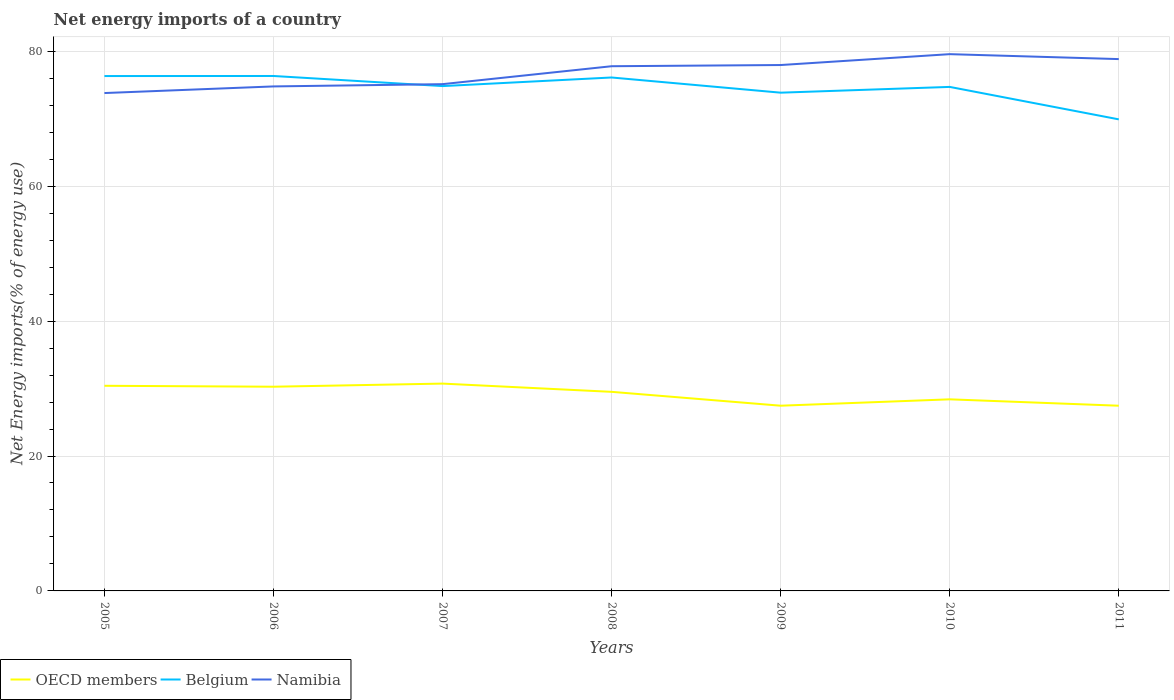How many different coloured lines are there?
Ensure brevity in your answer.  3. Is the number of lines equal to the number of legend labels?
Your answer should be very brief. Yes. Across all years, what is the maximum net energy imports in OECD members?
Your response must be concise. 27.46. What is the total net energy imports in Belgium in the graph?
Your answer should be compact. 2.46. What is the difference between the highest and the second highest net energy imports in OECD members?
Your response must be concise. 3.28. How many lines are there?
Your answer should be very brief. 3. What is the difference between two consecutive major ticks on the Y-axis?
Give a very brief answer. 20. Does the graph contain any zero values?
Keep it short and to the point. No. Does the graph contain grids?
Your response must be concise. Yes. Where does the legend appear in the graph?
Provide a short and direct response. Bottom left. How are the legend labels stacked?
Keep it short and to the point. Horizontal. What is the title of the graph?
Give a very brief answer. Net energy imports of a country. What is the label or title of the Y-axis?
Your answer should be compact. Net Energy imports(% of energy use). What is the Net Energy imports(% of energy use) in OECD members in 2005?
Make the answer very short. 30.41. What is the Net Energy imports(% of energy use) in Belgium in 2005?
Ensure brevity in your answer.  76.33. What is the Net Energy imports(% of energy use) in Namibia in 2005?
Offer a terse response. 73.81. What is the Net Energy imports(% of energy use) of OECD members in 2006?
Provide a short and direct response. 30.27. What is the Net Energy imports(% of energy use) of Belgium in 2006?
Offer a very short reply. 76.34. What is the Net Energy imports(% of energy use) of Namibia in 2006?
Your answer should be compact. 74.79. What is the Net Energy imports(% of energy use) in OECD members in 2007?
Offer a terse response. 30.73. What is the Net Energy imports(% of energy use) in Belgium in 2007?
Ensure brevity in your answer.  74.84. What is the Net Energy imports(% of energy use) in Namibia in 2007?
Offer a terse response. 75.13. What is the Net Energy imports(% of energy use) of OECD members in 2008?
Make the answer very short. 29.51. What is the Net Energy imports(% of energy use) of Belgium in 2008?
Offer a very short reply. 76.11. What is the Net Energy imports(% of energy use) in Namibia in 2008?
Keep it short and to the point. 77.78. What is the Net Energy imports(% of energy use) of OECD members in 2009?
Offer a terse response. 27.46. What is the Net Energy imports(% of energy use) in Belgium in 2009?
Provide a succinct answer. 73.86. What is the Net Energy imports(% of energy use) in Namibia in 2009?
Provide a short and direct response. 77.96. What is the Net Energy imports(% of energy use) in OECD members in 2010?
Make the answer very short. 28.4. What is the Net Energy imports(% of energy use) in Belgium in 2010?
Give a very brief answer. 74.72. What is the Net Energy imports(% of energy use) of Namibia in 2010?
Ensure brevity in your answer.  79.57. What is the Net Energy imports(% of energy use) in OECD members in 2011?
Provide a succinct answer. 27.46. What is the Net Energy imports(% of energy use) in Belgium in 2011?
Provide a succinct answer. 69.91. What is the Net Energy imports(% of energy use) of Namibia in 2011?
Offer a terse response. 78.84. Across all years, what is the maximum Net Energy imports(% of energy use) of OECD members?
Offer a very short reply. 30.73. Across all years, what is the maximum Net Energy imports(% of energy use) of Belgium?
Keep it short and to the point. 76.34. Across all years, what is the maximum Net Energy imports(% of energy use) of Namibia?
Offer a very short reply. 79.57. Across all years, what is the minimum Net Energy imports(% of energy use) in OECD members?
Your answer should be very brief. 27.46. Across all years, what is the minimum Net Energy imports(% of energy use) in Belgium?
Give a very brief answer. 69.91. Across all years, what is the minimum Net Energy imports(% of energy use) of Namibia?
Provide a succinct answer. 73.81. What is the total Net Energy imports(% of energy use) in OECD members in the graph?
Provide a short and direct response. 204.25. What is the total Net Energy imports(% of energy use) in Belgium in the graph?
Keep it short and to the point. 522.1. What is the total Net Energy imports(% of energy use) of Namibia in the graph?
Ensure brevity in your answer.  537.88. What is the difference between the Net Energy imports(% of energy use) of OECD members in 2005 and that in 2006?
Your response must be concise. 0.14. What is the difference between the Net Energy imports(% of energy use) in Belgium in 2005 and that in 2006?
Give a very brief answer. -0.01. What is the difference between the Net Energy imports(% of energy use) in Namibia in 2005 and that in 2006?
Make the answer very short. -0.98. What is the difference between the Net Energy imports(% of energy use) in OECD members in 2005 and that in 2007?
Provide a short and direct response. -0.32. What is the difference between the Net Energy imports(% of energy use) in Belgium in 2005 and that in 2007?
Give a very brief answer. 1.49. What is the difference between the Net Energy imports(% of energy use) of Namibia in 2005 and that in 2007?
Make the answer very short. -1.32. What is the difference between the Net Energy imports(% of energy use) of OECD members in 2005 and that in 2008?
Your answer should be very brief. 0.9. What is the difference between the Net Energy imports(% of energy use) in Belgium in 2005 and that in 2008?
Ensure brevity in your answer.  0.21. What is the difference between the Net Energy imports(% of energy use) in Namibia in 2005 and that in 2008?
Give a very brief answer. -3.98. What is the difference between the Net Energy imports(% of energy use) of OECD members in 2005 and that in 2009?
Your answer should be compact. 2.95. What is the difference between the Net Energy imports(% of energy use) of Belgium in 2005 and that in 2009?
Your answer should be very brief. 2.46. What is the difference between the Net Energy imports(% of energy use) in Namibia in 2005 and that in 2009?
Provide a short and direct response. -4.15. What is the difference between the Net Energy imports(% of energy use) of OECD members in 2005 and that in 2010?
Make the answer very short. 2.01. What is the difference between the Net Energy imports(% of energy use) of Belgium in 2005 and that in 2010?
Ensure brevity in your answer.  1.61. What is the difference between the Net Energy imports(% of energy use) in Namibia in 2005 and that in 2010?
Offer a terse response. -5.76. What is the difference between the Net Energy imports(% of energy use) of OECD members in 2005 and that in 2011?
Provide a succinct answer. 2.96. What is the difference between the Net Energy imports(% of energy use) of Belgium in 2005 and that in 2011?
Make the answer very short. 6.42. What is the difference between the Net Energy imports(% of energy use) of Namibia in 2005 and that in 2011?
Your response must be concise. -5.03. What is the difference between the Net Energy imports(% of energy use) of OECD members in 2006 and that in 2007?
Provide a succinct answer. -0.46. What is the difference between the Net Energy imports(% of energy use) of Belgium in 2006 and that in 2007?
Offer a very short reply. 1.5. What is the difference between the Net Energy imports(% of energy use) of Namibia in 2006 and that in 2007?
Provide a succinct answer. -0.34. What is the difference between the Net Energy imports(% of energy use) in OECD members in 2006 and that in 2008?
Provide a short and direct response. 0.76. What is the difference between the Net Energy imports(% of energy use) in Belgium in 2006 and that in 2008?
Give a very brief answer. 0.22. What is the difference between the Net Energy imports(% of energy use) of Namibia in 2006 and that in 2008?
Your answer should be very brief. -3. What is the difference between the Net Energy imports(% of energy use) of OECD members in 2006 and that in 2009?
Give a very brief answer. 2.82. What is the difference between the Net Energy imports(% of energy use) in Belgium in 2006 and that in 2009?
Offer a terse response. 2.47. What is the difference between the Net Energy imports(% of energy use) of Namibia in 2006 and that in 2009?
Give a very brief answer. -3.17. What is the difference between the Net Energy imports(% of energy use) of OECD members in 2006 and that in 2010?
Your answer should be compact. 1.87. What is the difference between the Net Energy imports(% of energy use) in Belgium in 2006 and that in 2010?
Offer a very short reply. 1.62. What is the difference between the Net Energy imports(% of energy use) in Namibia in 2006 and that in 2010?
Your response must be concise. -4.78. What is the difference between the Net Energy imports(% of energy use) in OECD members in 2006 and that in 2011?
Provide a succinct answer. 2.82. What is the difference between the Net Energy imports(% of energy use) in Belgium in 2006 and that in 2011?
Offer a terse response. 6.43. What is the difference between the Net Energy imports(% of energy use) in Namibia in 2006 and that in 2011?
Give a very brief answer. -4.05. What is the difference between the Net Energy imports(% of energy use) of OECD members in 2007 and that in 2008?
Ensure brevity in your answer.  1.22. What is the difference between the Net Energy imports(% of energy use) of Belgium in 2007 and that in 2008?
Offer a terse response. -1.27. What is the difference between the Net Energy imports(% of energy use) of Namibia in 2007 and that in 2008?
Ensure brevity in your answer.  -2.66. What is the difference between the Net Energy imports(% of energy use) of OECD members in 2007 and that in 2009?
Your answer should be very brief. 3.28. What is the difference between the Net Energy imports(% of energy use) in Belgium in 2007 and that in 2009?
Your answer should be very brief. 0.98. What is the difference between the Net Energy imports(% of energy use) of Namibia in 2007 and that in 2009?
Provide a succinct answer. -2.83. What is the difference between the Net Energy imports(% of energy use) of OECD members in 2007 and that in 2010?
Offer a very short reply. 2.33. What is the difference between the Net Energy imports(% of energy use) of Belgium in 2007 and that in 2010?
Offer a very short reply. 0.12. What is the difference between the Net Energy imports(% of energy use) of Namibia in 2007 and that in 2010?
Make the answer very short. -4.45. What is the difference between the Net Energy imports(% of energy use) of OECD members in 2007 and that in 2011?
Provide a succinct answer. 3.28. What is the difference between the Net Energy imports(% of energy use) of Belgium in 2007 and that in 2011?
Your answer should be compact. 4.93. What is the difference between the Net Energy imports(% of energy use) of Namibia in 2007 and that in 2011?
Your answer should be compact. -3.71. What is the difference between the Net Energy imports(% of energy use) in OECD members in 2008 and that in 2009?
Offer a very short reply. 2.06. What is the difference between the Net Energy imports(% of energy use) in Belgium in 2008 and that in 2009?
Offer a terse response. 2.25. What is the difference between the Net Energy imports(% of energy use) in Namibia in 2008 and that in 2009?
Provide a short and direct response. -0.18. What is the difference between the Net Energy imports(% of energy use) of OECD members in 2008 and that in 2010?
Offer a very short reply. 1.11. What is the difference between the Net Energy imports(% of energy use) of Belgium in 2008 and that in 2010?
Make the answer very short. 1.4. What is the difference between the Net Energy imports(% of energy use) in Namibia in 2008 and that in 2010?
Offer a terse response. -1.79. What is the difference between the Net Energy imports(% of energy use) of OECD members in 2008 and that in 2011?
Give a very brief answer. 2.06. What is the difference between the Net Energy imports(% of energy use) of Belgium in 2008 and that in 2011?
Provide a short and direct response. 6.21. What is the difference between the Net Energy imports(% of energy use) of Namibia in 2008 and that in 2011?
Your answer should be compact. -1.06. What is the difference between the Net Energy imports(% of energy use) of OECD members in 2009 and that in 2010?
Ensure brevity in your answer.  -0.95. What is the difference between the Net Energy imports(% of energy use) in Belgium in 2009 and that in 2010?
Keep it short and to the point. -0.86. What is the difference between the Net Energy imports(% of energy use) of Namibia in 2009 and that in 2010?
Ensure brevity in your answer.  -1.61. What is the difference between the Net Energy imports(% of energy use) of OECD members in 2009 and that in 2011?
Your response must be concise. 0. What is the difference between the Net Energy imports(% of energy use) of Belgium in 2009 and that in 2011?
Your answer should be compact. 3.96. What is the difference between the Net Energy imports(% of energy use) of Namibia in 2009 and that in 2011?
Your response must be concise. -0.88. What is the difference between the Net Energy imports(% of energy use) in OECD members in 2010 and that in 2011?
Your answer should be compact. 0.95. What is the difference between the Net Energy imports(% of energy use) of Belgium in 2010 and that in 2011?
Provide a succinct answer. 4.81. What is the difference between the Net Energy imports(% of energy use) in Namibia in 2010 and that in 2011?
Offer a very short reply. 0.73. What is the difference between the Net Energy imports(% of energy use) of OECD members in 2005 and the Net Energy imports(% of energy use) of Belgium in 2006?
Your response must be concise. -45.93. What is the difference between the Net Energy imports(% of energy use) of OECD members in 2005 and the Net Energy imports(% of energy use) of Namibia in 2006?
Give a very brief answer. -44.38. What is the difference between the Net Energy imports(% of energy use) of Belgium in 2005 and the Net Energy imports(% of energy use) of Namibia in 2006?
Offer a terse response. 1.54. What is the difference between the Net Energy imports(% of energy use) in OECD members in 2005 and the Net Energy imports(% of energy use) in Belgium in 2007?
Keep it short and to the point. -44.43. What is the difference between the Net Energy imports(% of energy use) of OECD members in 2005 and the Net Energy imports(% of energy use) of Namibia in 2007?
Ensure brevity in your answer.  -44.72. What is the difference between the Net Energy imports(% of energy use) in Belgium in 2005 and the Net Energy imports(% of energy use) in Namibia in 2007?
Offer a very short reply. 1.2. What is the difference between the Net Energy imports(% of energy use) in OECD members in 2005 and the Net Energy imports(% of energy use) in Belgium in 2008?
Your answer should be very brief. -45.7. What is the difference between the Net Energy imports(% of energy use) of OECD members in 2005 and the Net Energy imports(% of energy use) of Namibia in 2008?
Ensure brevity in your answer.  -47.37. What is the difference between the Net Energy imports(% of energy use) of Belgium in 2005 and the Net Energy imports(% of energy use) of Namibia in 2008?
Keep it short and to the point. -1.46. What is the difference between the Net Energy imports(% of energy use) in OECD members in 2005 and the Net Energy imports(% of energy use) in Belgium in 2009?
Your answer should be very brief. -43.45. What is the difference between the Net Energy imports(% of energy use) of OECD members in 2005 and the Net Energy imports(% of energy use) of Namibia in 2009?
Offer a terse response. -47.55. What is the difference between the Net Energy imports(% of energy use) of Belgium in 2005 and the Net Energy imports(% of energy use) of Namibia in 2009?
Offer a very short reply. -1.63. What is the difference between the Net Energy imports(% of energy use) in OECD members in 2005 and the Net Energy imports(% of energy use) in Belgium in 2010?
Your answer should be compact. -44.31. What is the difference between the Net Energy imports(% of energy use) in OECD members in 2005 and the Net Energy imports(% of energy use) in Namibia in 2010?
Provide a short and direct response. -49.16. What is the difference between the Net Energy imports(% of energy use) in Belgium in 2005 and the Net Energy imports(% of energy use) in Namibia in 2010?
Make the answer very short. -3.25. What is the difference between the Net Energy imports(% of energy use) of OECD members in 2005 and the Net Energy imports(% of energy use) of Belgium in 2011?
Provide a succinct answer. -39.5. What is the difference between the Net Energy imports(% of energy use) of OECD members in 2005 and the Net Energy imports(% of energy use) of Namibia in 2011?
Offer a terse response. -48.43. What is the difference between the Net Energy imports(% of energy use) of Belgium in 2005 and the Net Energy imports(% of energy use) of Namibia in 2011?
Provide a short and direct response. -2.51. What is the difference between the Net Energy imports(% of energy use) in OECD members in 2006 and the Net Energy imports(% of energy use) in Belgium in 2007?
Offer a very short reply. -44.57. What is the difference between the Net Energy imports(% of energy use) in OECD members in 2006 and the Net Energy imports(% of energy use) in Namibia in 2007?
Provide a succinct answer. -44.85. What is the difference between the Net Energy imports(% of energy use) in Belgium in 2006 and the Net Energy imports(% of energy use) in Namibia in 2007?
Make the answer very short. 1.21. What is the difference between the Net Energy imports(% of energy use) of OECD members in 2006 and the Net Energy imports(% of energy use) of Belgium in 2008?
Offer a terse response. -45.84. What is the difference between the Net Energy imports(% of energy use) in OECD members in 2006 and the Net Energy imports(% of energy use) in Namibia in 2008?
Provide a short and direct response. -47.51. What is the difference between the Net Energy imports(% of energy use) in Belgium in 2006 and the Net Energy imports(% of energy use) in Namibia in 2008?
Your answer should be very brief. -1.45. What is the difference between the Net Energy imports(% of energy use) in OECD members in 2006 and the Net Energy imports(% of energy use) in Belgium in 2009?
Ensure brevity in your answer.  -43.59. What is the difference between the Net Energy imports(% of energy use) in OECD members in 2006 and the Net Energy imports(% of energy use) in Namibia in 2009?
Your response must be concise. -47.69. What is the difference between the Net Energy imports(% of energy use) in Belgium in 2006 and the Net Energy imports(% of energy use) in Namibia in 2009?
Offer a terse response. -1.62. What is the difference between the Net Energy imports(% of energy use) in OECD members in 2006 and the Net Energy imports(% of energy use) in Belgium in 2010?
Keep it short and to the point. -44.45. What is the difference between the Net Energy imports(% of energy use) in OECD members in 2006 and the Net Energy imports(% of energy use) in Namibia in 2010?
Your response must be concise. -49.3. What is the difference between the Net Energy imports(% of energy use) of Belgium in 2006 and the Net Energy imports(% of energy use) of Namibia in 2010?
Provide a short and direct response. -3.24. What is the difference between the Net Energy imports(% of energy use) in OECD members in 2006 and the Net Energy imports(% of energy use) in Belgium in 2011?
Provide a short and direct response. -39.63. What is the difference between the Net Energy imports(% of energy use) of OECD members in 2006 and the Net Energy imports(% of energy use) of Namibia in 2011?
Offer a terse response. -48.57. What is the difference between the Net Energy imports(% of energy use) in Belgium in 2006 and the Net Energy imports(% of energy use) in Namibia in 2011?
Offer a very short reply. -2.5. What is the difference between the Net Energy imports(% of energy use) in OECD members in 2007 and the Net Energy imports(% of energy use) in Belgium in 2008?
Your response must be concise. -45.38. What is the difference between the Net Energy imports(% of energy use) in OECD members in 2007 and the Net Energy imports(% of energy use) in Namibia in 2008?
Keep it short and to the point. -47.05. What is the difference between the Net Energy imports(% of energy use) in Belgium in 2007 and the Net Energy imports(% of energy use) in Namibia in 2008?
Your answer should be very brief. -2.94. What is the difference between the Net Energy imports(% of energy use) in OECD members in 2007 and the Net Energy imports(% of energy use) in Belgium in 2009?
Ensure brevity in your answer.  -43.13. What is the difference between the Net Energy imports(% of energy use) of OECD members in 2007 and the Net Energy imports(% of energy use) of Namibia in 2009?
Make the answer very short. -47.23. What is the difference between the Net Energy imports(% of energy use) in Belgium in 2007 and the Net Energy imports(% of energy use) in Namibia in 2009?
Offer a very short reply. -3.12. What is the difference between the Net Energy imports(% of energy use) in OECD members in 2007 and the Net Energy imports(% of energy use) in Belgium in 2010?
Provide a succinct answer. -43.98. What is the difference between the Net Energy imports(% of energy use) in OECD members in 2007 and the Net Energy imports(% of energy use) in Namibia in 2010?
Offer a very short reply. -48.84. What is the difference between the Net Energy imports(% of energy use) of Belgium in 2007 and the Net Energy imports(% of energy use) of Namibia in 2010?
Offer a terse response. -4.73. What is the difference between the Net Energy imports(% of energy use) of OECD members in 2007 and the Net Energy imports(% of energy use) of Belgium in 2011?
Ensure brevity in your answer.  -39.17. What is the difference between the Net Energy imports(% of energy use) of OECD members in 2007 and the Net Energy imports(% of energy use) of Namibia in 2011?
Offer a very short reply. -48.11. What is the difference between the Net Energy imports(% of energy use) of Belgium in 2007 and the Net Energy imports(% of energy use) of Namibia in 2011?
Provide a short and direct response. -4. What is the difference between the Net Energy imports(% of energy use) in OECD members in 2008 and the Net Energy imports(% of energy use) in Belgium in 2009?
Offer a terse response. -44.35. What is the difference between the Net Energy imports(% of energy use) of OECD members in 2008 and the Net Energy imports(% of energy use) of Namibia in 2009?
Ensure brevity in your answer.  -48.45. What is the difference between the Net Energy imports(% of energy use) of Belgium in 2008 and the Net Energy imports(% of energy use) of Namibia in 2009?
Offer a terse response. -1.85. What is the difference between the Net Energy imports(% of energy use) of OECD members in 2008 and the Net Energy imports(% of energy use) of Belgium in 2010?
Offer a terse response. -45.21. What is the difference between the Net Energy imports(% of energy use) in OECD members in 2008 and the Net Energy imports(% of energy use) in Namibia in 2010?
Your response must be concise. -50.06. What is the difference between the Net Energy imports(% of energy use) of Belgium in 2008 and the Net Energy imports(% of energy use) of Namibia in 2010?
Your response must be concise. -3.46. What is the difference between the Net Energy imports(% of energy use) of OECD members in 2008 and the Net Energy imports(% of energy use) of Belgium in 2011?
Offer a terse response. -40.39. What is the difference between the Net Energy imports(% of energy use) in OECD members in 2008 and the Net Energy imports(% of energy use) in Namibia in 2011?
Ensure brevity in your answer.  -49.33. What is the difference between the Net Energy imports(% of energy use) in Belgium in 2008 and the Net Energy imports(% of energy use) in Namibia in 2011?
Keep it short and to the point. -2.73. What is the difference between the Net Energy imports(% of energy use) in OECD members in 2009 and the Net Energy imports(% of energy use) in Belgium in 2010?
Offer a terse response. -47.26. What is the difference between the Net Energy imports(% of energy use) in OECD members in 2009 and the Net Energy imports(% of energy use) in Namibia in 2010?
Your response must be concise. -52.12. What is the difference between the Net Energy imports(% of energy use) in Belgium in 2009 and the Net Energy imports(% of energy use) in Namibia in 2010?
Provide a succinct answer. -5.71. What is the difference between the Net Energy imports(% of energy use) in OECD members in 2009 and the Net Energy imports(% of energy use) in Belgium in 2011?
Your answer should be compact. -42.45. What is the difference between the Net Energy imports(% of energy use) of OECD members in 2009 and the Net Energy imports(% of energy use) of Namibia in 2011?
Provide a succinct answer. -51.38. What is the difference between the Net Energy imports(% of energy use) of Belgium in 2009 and the Net Energy imports(% of energy use) of Namibia in 2011?
Keep it short and to the point. -4.98. What is the difference between the Net Energy imports(% of energy use) in OECD members in 2010 and the Net Energy imports(% of energy use) in Belgium in 2011?
Your answer should be compact. -41.5. What is the difference between the Net Energy imports(% of energy use) in OECD members in 2010 and the Net Energy imports(% of energy use) in Namibia in 2011?
Keep it short and to the point. -50.44. What is the difference between the Net Energy imports(% of energy use) of Belgium in 2010 and the Net Energy imports(% of energy use) of Namibia in 2011?
Offer a very short reply. -4.12. What is the average Net Energy imports(% of energy use) in OECD members per year?
Offer a terse response. 29.18. What is the average Net Energy imports(% of energy use) in Belgium per year?
Keep it short and to the point. 74.59. What is the average Net Energy imports(% of energy use) in Namibia per year?
Provide a short and direct response. 76.84. In the year 2005, what is the difference between the Net Energy imports(% of energy use) in OECD members and Net Energy imports(% of energy use) in Belgium?
Give a very brief answer. -45.92. In the year 2005, what is the difference between the Net Energy imports(% of energy use) of OECD members and Net Energy imports(% of energy use) of Namibia?
Your response must be concise. -43.4. In the year 2005, what is the difference between the Net Energy imports(% of energy use) of Belgium and Net Energy imports(% of energy use) of Namibia?
Your answer should be compact. 2.52. In the year 2006, what is the difference between the Net Energy imports(% of energy use) in OECD members and Net Energy imports(% of energy use) in Belgium?
Offer a terse response. -46.06. In the year 2006, what is the difference between the Net Energy imports(% of energy use) of OECD members and Net Energy imports(% of energy use) of Namibia?
Your response must be concise. -44.52. In the year 2006, what is the difference between the Net Energy imports(% of energy use) of Belgium and Net Energy imports(% of energy use) of Namibia?
Offer a very short reply. 1.55. In the year 2007, what is the difference between the Net Energy imports(% of energy use) of OECD members and Net Energy imports(% of energy use) of Belgium?
Provide a succinct answer. -44.1. In the year 2007, what is the difference between the Net Energy imports(% of energy use) in OECD members and Net Energy imports(% of energy use) in Namibia?
Offer a very short reply. -44.39. In the year 2007, what is the difference between the Net Energy imports(% of energy use) in Belgium and Net Energy imports(% of energy use) in Namibia?
Ensure brevity in your answer.  -0.29. In the year 2008, what is the difference between the Net Energy imports(% of energy use) in OECD members and Net Energy imports(% of energy use) in Belgium?
Offer a terse response. -46.6. In the year 2008, what is the difference between the Net Energy imports(% of energy use) of OECD members and Net Energy imports(% of energy use) of Namibia?
Provide a succinct answer. -48.27. In the year 2008, what is the difference between the Net Energy imports(% of energy use) of Belgium and Net Energy imports(% of energy use) of Namibia?
Make the answer very short. -1.67. In the year 2009, what is the difference between the Net Energy imports(% of energy use) of OECD members and Net Energy imports(% of energy use) of Belgium?
Your answer should be very brief. -46.41. In the year 2009, what is the difference between the Net Energy imports(% of energy use) in OECD members and Net Energy imports(% of energy use) in Namibia?
Your answer should be very brief. -50.5. In the year 2009, what is the difference between the Net Energy imports(% of energy use) in Belgium and Net Energy imports(% of energy use) in Namibia?
Keep it short and to the point. -4.1. In the year 2010, what is the difference between the Net Energy imports(% of energy use) in OECD members and Net Energy imports(% of energy use) in Belgium?
Your answer should be very brief. -46.31. In the year 2010, what is the difference between the Net Energy imports(% of energy use) in OECD members and Net Energy imports(% of energy use) in Namibia?
Give a very brief answer. -51.17. In the year 2010, what is the difference between the Net Energy imports(% of energy use) in Belgium and Net Energy imports(% of energy use) in Namibia?
Offer a terse response. -4.85. In the year 2011, what is the difference between the Net Energy imports(% of energy use) in OECD members and Net Energy imports(% of energy use) in Belgium?
Provide a succinct answer. -42.45. In the year 2011, what is the difference between the Net Energy imports(% of energy use) of OECD members and Net Energy imports(% of energy use) of Namibia?
Offer a terse response. -51.39. In the year 2011, what is the difference between the Net Energy imports(% of energy use) in Belgium and Net Energy imports(% of energy use) in Namibia?
Your answer should be compact. -8.93. What is the ratio of the Net Energy imports(% of energy use) in OECD members in 2005 to that in 2006?
Give a very brief answer. 1. What is the ratio of the Net Energy imports(% of energy use) in Belgium in 2005 to that in 2006?
Keep it short and to the point. 1. What is the ratio of the Net Energy imports(% of energy use) in Namibia in 2005 to that in 2006?
Provide a succinct answer. 0.99. What is the ratio of the Net Energy imports(% of energy use) of Belgium in 2005 to that in 2007?
Give a very brief answer. 1.02. What is the ratio of the Net Energy imports(% of energy use) in Namibia in 2005 to that in 2007?
Keep it short and to the point. 0.98. What is the ratio of the Net Energy imports(% of energy use) in OECD members in 2005 to that in 2008?
Keep it short and to the point. 1.03. What is the ratio of the Net Energy imports(% of energy use) of Belgium in 2005 to that in 2008?
Give a very brief answer. 1. What is the ratio of the Net Energy imports(% of energy use) in Namibia in 2005 to that in 2008?
Offer a very short reply. 0.95. What is the ratio of the Net Energy imports(% of energy use) of OECD members in 2005 to that in 2009?
Your answer should be very brief. 1.11. What is the ratio of the Net Energy imports(% of energy use) of Belgium in 2005 to that in 2009?
Your answer should be compact. 1.03. What is the ratio of the Net Energy imports(% of energy use) in Namibia in 2005 to that in 2009?
Your answer should be very brief. 0.95. What is the ratio of the Net Energy imports(% of energy use) of OECD members in 2005 to that in 2010?
Your response must be concise. 1.07. What is the ratio of the Net Energy imports(% of energy use) in Belgium in 2005 to that in 2010?
Offer a terse response. 1.02. What is the ratio of the Net Energy imports(% of energy use) in Namibia in 2005 to that in 2010?
Offer a very short reply. 0.93. What is the ratio of the Net Energy imports(% of energy use) in OECD members in 2005 to that in 2011?
Provide a succinct answer. 1.11. What is the ratio of the Net Energy imports(% of energy use) of Belgium in 2005 to that in 2011?
Provide a short and direct response. 1.09. What is the ratio of the Net Energy imports(% of energy use) of Namibia in 2005 to that in 2011?
Your answer should be very brief. 0.94. What is the ratio of the Net Energy imports(% of energy use) in OECD members in 2006 to that in 2007?
Offer a very short reply. 0.98. What is the ratio of the Net Energy imports(% of energy use) in Namibia in 2006 to that in 2007?
Give a very brief answer. 1. What is the ratio of the Net Energy imports(% of energy use) in OECD members in 2006 to that in 2008?
Your answer should be compact. 1.03. What is the ratio of the Net Energy imports(% of energy use) of Namibia in 2006 to that in 2008?
Offer a terse response. 0.96. What is the ratio of the Net Energy imports(% of energy use) in OECD members in 2006 to that in 2009?
Provide a succinct answer. 1.1. What is the ratio of the Net Energy imports(% of energy use) of Belgium in 2006 to that in 2009?
Your response must be concise. 1.03. What is the ratio of the Net Energy imports(% of energy use) in Namibia in 2006 to that in 2009?
Offer a very short reply. 0.96. What is the ratio of the Net Energy imports(% of energy use) of OECD members in 2006 to that in 2010?
Provide a succinct answer. 1.07. What is the ratio of the Net Energy imports(% of energy use) in Belgium in 2006 to that in 2010?
Offer a very short reply. 1.02. What is the ratio of the Net Energy imports(% of energy use) in Namibia in 2006 to that in 2010?
Provide a succinct answer. 0.94. What is the ratio of the Net Energy imports(% of energy use) in OECD members in 2006 to that in 2011?
Your answer should be very brief. 1.1. What is the ratio of the Net Energy imports(% of energy use) of Belgium in 2006 to that in 2011?
Give a very brief answer. 1.09. What is the ratio of the Net Energy imports(% of energy use) in Namibia in 2006 to that in 2011?
Provide a succinct answer. 0.95. What is the ratio of the Net Energy imports(% of energy use) of OECD members in 2007 to that in 2008?
Your answer should be very brief. 1.04. What is the ratio of the Net Energy imports(% of energy use) in Belgium in 2007 to that in 2008?
Keep it short and to the point. 0.98. What is the ratio of the Net Energy imports(% of energy use) of Namibia in 2007 to that in 2008?
Keep it short and to the point. 0.97. What is the ratio of the Net Energy imports(% of energy use) in OECD members in 2007 to that in 2009?
Keep it short and to the point. 1.12. What is the ratio of the Net Energy imports(% of energy use) in Belgium in 2007 to that in 2009?
Your answer should be very brief. 1.01. What is the ratio of the Net Energy imports(% of energy use) in Namibia in 2007 to that in 2009?
Keep it short and to the point. 0.96. What is the ratio of the Net Energy imports(% of energy use) of OECD members in 2007 to that in 2010?
Ensure brevity in your answer.  1.08. What is the ratio of the Net Energy imports(% of energy use) in Belgium in 2007 to that in 2010?
Make the answer very short. 1. What is the ratio of the Net Energy imports(% of energy use) of Namibia in 2007 to that in 2010?
Provide a succinct answer. 0.94. What is the ratio of the Net Energy imports(% of energy use) of OECD members in 2007 to that in 2011?
Provide a short and direct response. 1.12. What is the ratio of the Net Energy imports(% of energy use) of Belgium in 2007 to that in 2011?
Provide a succinct answer. 1.07. What is the ratio of the Net Energy imports(% of energy use) in Namibia in 2007 to that in 2011?
Make the answer very short. 0.95. What is the ratio of the Net Energy imports(% of energy use) of OECD members in 2008 to that in 2009?
Give a very brief answer. 1.07. What is the ratio of the Net Energy imports(% of energy use) of Belgium in 2008 to that in 2009?
Keep it short and to the point. 1.03. What is the ratio of the Net Energy imports(% of energy use) in OECD members in 2008 to that in 2010?
Offer a terse response. 1.04. What is the ratio of the Net Energy imports(% of energy use) in Belgium in 2008 to that in 2010?
Provide a short and direct response. 1.02. What is the ratio of the Net Energy imports(% of energy use) of Namibia in 2008 to that in 2010?
Offer a very short reply. 0.98. What is the ratio of the Net Energy imports(% of energy use) of OECD members in 2008 to that in 2011?
Provide a short and direct response. 1.07. What is the ratio of the Net Energy imports(% of energy use) in Belgium in 2008 to that in 2011?
Your answer should be compact. 1.09. What is the ratio of the Net Energy imports(% of energy use) of Namibia in 2008 to that in 2011?
Ensure brevity in your answer.  0.99. What is the ratio of the Net Energy imports(% of energy use) in OECD members in 2009 to that in 2010?
Provide a short and direct response. 0.97. What is the ratio of the Net Energy imports(% of energy use) in Belgium in 2009 to that in 2010?
Offer a terse response. 0.99. What is the ratio of the Net Energy imports(% of energy use) in Namibia in 2009 to that in 2010?
Keep it short and to the point. 0.98. What is the ratio of the Net Energy imports(% of energy use) of OECD members in 2009 to that in 2011?
Provide a short and direct response. 1. What is the ratio of the Net Energy imports(% of energy use) of Belgium in 2009 to that in 2011?
Your answer should be compact. 1.06. What is the ratio of the Net Energy imports(% of energy use) in OECD members in 2010 to that in 2011?
Give a very brief answer. 1.03. What is the ratio of the Net Energy imports(% of energy use) of Belgium in 2010 to that in 2011?
Offer a very short reply. 1.07. What is the ratio of the Net Energy imports(% of energy use) in Namibia in 2010 to that in 2011?
Your response must be concise. 1.01. What is the difference between the highest and the second highest Net Energy imports(% of energy use) of OECD members?
Offer a terse response. 0.32. What is the difference between the highest and the second highest Net Energy imports(% of energy use) of Belgium?
Your response must be concise. 0.01. What is the difference between the highest and the second highest Net Energy imports(% of energy use) in Namibia?
Give a very brief answer. 0.73. What is the difference between the highest and the lowest Net Energy imports(% of energy use) of OECD members?
Provide a short and direct response. 3.28. What is the difference between the highest and the lowest Net Energy imports(% of energy use) of Belgium?
Provide a succinct answer. 6.43. What is the difference between the highest and the lowest Net Energy imports(% of energy use) of Namibia?
Your response must be concise. 5.76. 